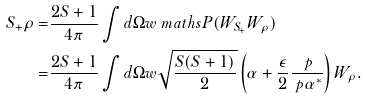<formula> <loc_0><loc_0><loc_500><loc_500>S _ { + } \rho = & \frac { 2 S + 1 } { 4 \pi } \int d \Omega w \ m a t h s { P } ( W _ { S _ { + } } W _ { \rho } ) \\ = & \frac { 2 S + 1 } { 4 \pi } \int d \Omega w \sqrt { \frac { S ( S + 1 ) } { 2 } } \left ( \alpha + \frac { \epsilon } { 2 } \frac { \ p } { \ p \alpha ^ { * } } \right ) W _ { \rho } .</formula> 